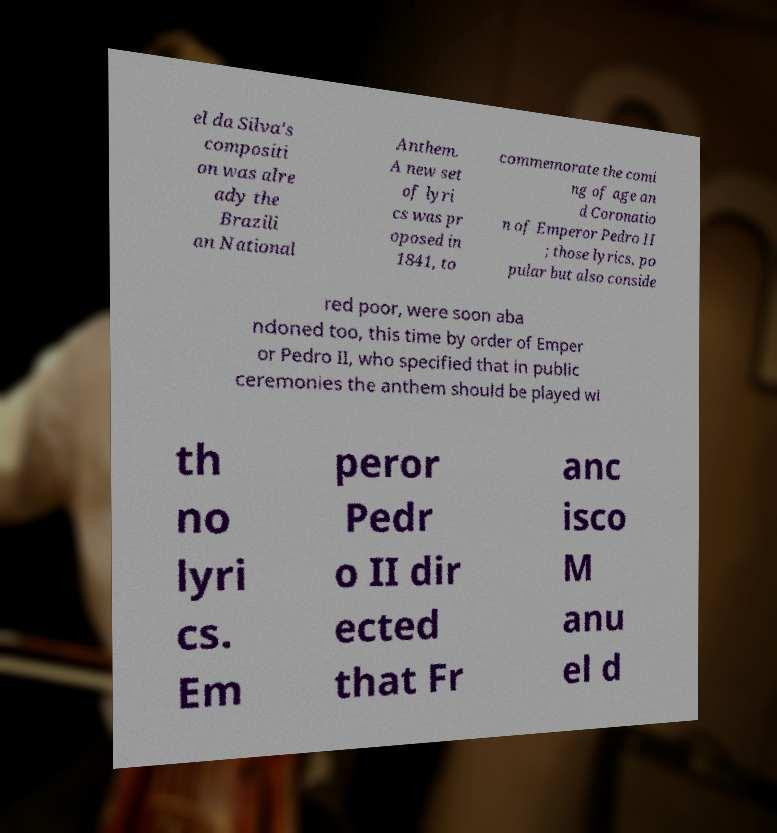Please read and relay the text visible in this image. What does it say? el da Silva's compositi on was alre ady the Brazili an National Anthem. A new set of lyri cs was pr oposed in 1841, to commemorate the comi ng of age an d Coronatio n of Emperor Pedro II ; those lyrics, po pular but also conside red poor, were soon aba ndoned too, this time by order of Emper or Pedro II, who specified that in public ceremonies the anthem should be played wi th no lyri cs. Em peror Pedr o II dir ected that Fr anc isco M anu el d 